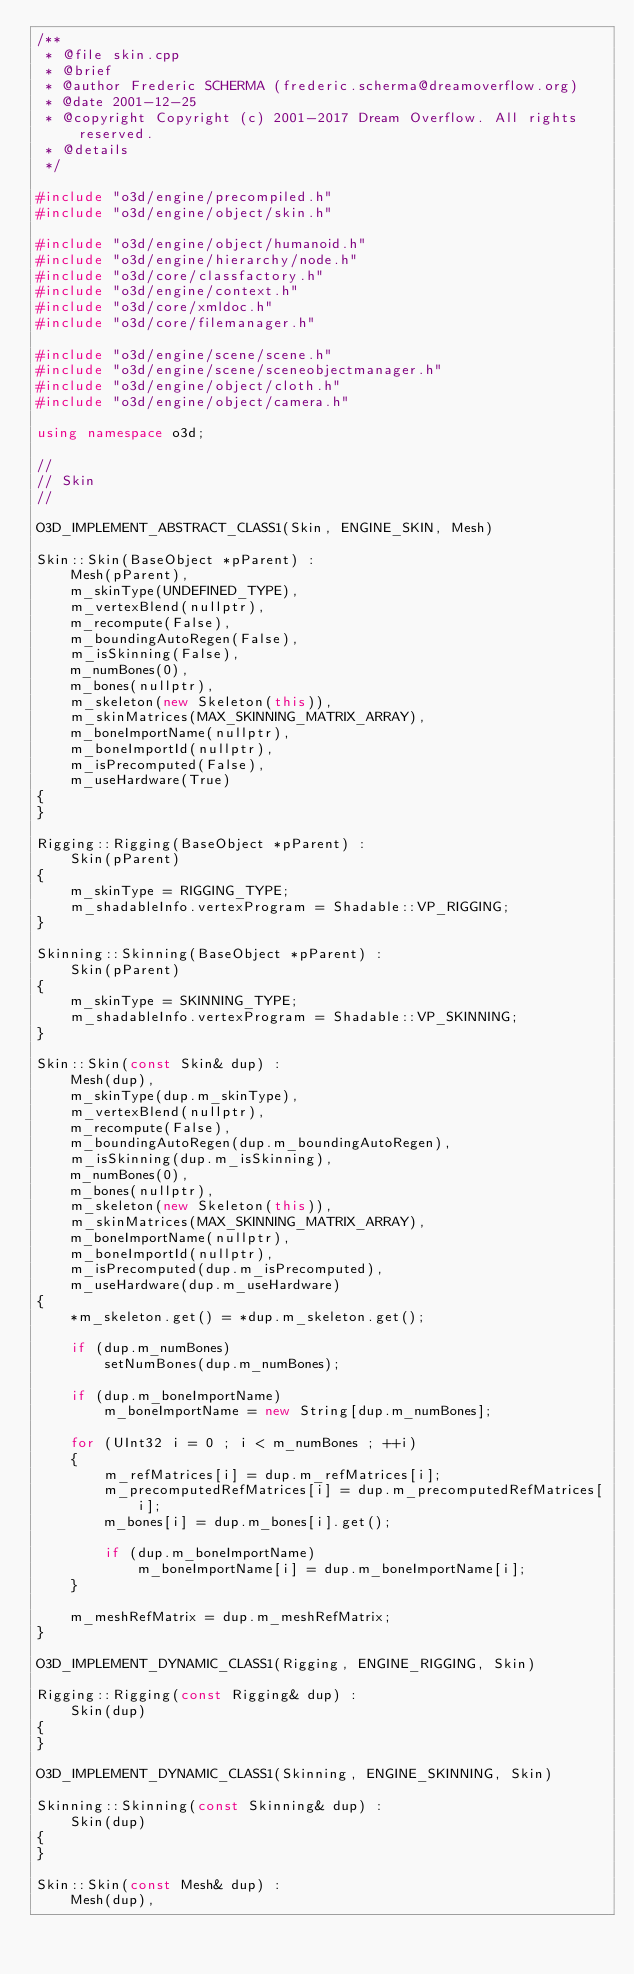Convert code to text. <code><loc_0><loc_0><loc_500><loc_500><_C++_>/**
 * @file skin.cpp
 * @brief 
 * @author Frederic SCHERMA (frederic.scherma@dreamoverflow.org)
 * @date 2001-12-25
 * @copyright Copyright (c) 2001-2017 Dream Overflow. All rights reserved.
 * @details 
 */

#include "o3d/engine/precompiled.h"
#include "o3d/engine/object/skin.h"

#include "o3d/engine/object/humanoid.h"
#include "o3d/engine/hierarchy/node.h"
#include "o3d/core/classfactory.h"
#include "o3d/engine/context.h"
#include "o3d/core/xmldoc.h"
#include "o3d/core/filemanager.h"

#include "o3d/engine/scene/scene.h"
#include "o3d/engine/scene/sceneobjectmanager.h"
#include "o3d/engine/object/cloth.h"
#include "o3d/engine/object/camera.h"

using namespace o3d;

//
// Skin
//

O3D_IMPLEMENT_ABSTRACT_CLASS1(Skin, ENGINE_SKIN, Mesh)

Skin::Skin(BaseObject *pParent) :
    Mesh(pParent),
    m_skinType(UNDEFINED_TYPE),
    m_vertexBlend(nullptr),
    m_recompute(False),
    m_boundingAutoRegen(False),
    m_isSkinning(False),
    m_numBones(0),
    m_bones(nullptr),
    m_skeleton(new Skeleton(this)),
    m_skinMatrices(MAX_SKINNING_MATRIX_ARRAY),
    m_boneImportName(nullptr),
    m_boneImportId(nullptr),
    m_isPrecomputed(False),
    m_useHardware(True)
{
}

Rigging::Rigging(BaseObject *pParent) :
    Skin(pParent)
{
    m_skinType = RIGGING_TYPE;
    m_shadableInfo.vertexProgram = Shadable::VP_RIGGING;
}

Skinning::Skinning(BaseObject *pParent) :
    Skin(pParent)
{
    m_skinType = SKINNING_TYPE;
    m_shadableInfo.vertexProgram = Shadable::VP_SKINNING;
}

Skin::Skin(const Skin& dup) :
    Mesh(dup),
    m_skinType(dup.m_skinType),
    m_vertexBlend(nullptr),
    m_recompute(False),
    m_boundingAutoRegen(dup.m_boundingAutoRegen),
    m_isSkinning(dup.m_isSkinning),
    m_numBones(0),
    m_bones(nullptr),
    m_skeleton(new Skeleton(this)),
    m_skinMatrices(MAX_SKINNING_MATRIX_ARRAY),
    m_boneImportName(nullptr),
    m_boneImportId(nullptr),
    m_isPrecomputed(dup.m_isPrecomputed),
    m_useHardware(dup.m_useHardware)
{
    *m_skeleton.get() = *dup.m_skeleton.get();

    if (dup.m_numBones)
        setNumBones(dup.m_numBones);

    if (dup.m_boneImportName)
        m_boneImportName = new String[dup.m_numBones];

    for (UInt32 i = 0 ; i < m_numBones ; ++i)
    {
        m_refMatrices[i] = dup.m_refMatrices[i];
        m_precomputedRefMatrices[i] = dup.m_precomputedRefMatrices[i];
        m_bones[i] = dup.m_bones[i].get();

        if (dup.m_boneImportName)
            m_boneImportName[i] = dup.m_boneImportName[i];
    }

    m_meshRefMatrix = dup.m_meshRefMatrix;
}

O3D_IMPLEMENT_DYNAMIC_CLASS1(Rigging, ENGINE_RIGGING, Skin)

Rigging::Rigging(const Rigging& dup) :
    Skin(dup)
{
}

O3D_IMPLEMENT_DYNAMIC_CLASS1(Skinning, ENGINE_SKINNING, Skin)

Skinning::Skinning(const Skinning& dup) :
    Skin(dup)
{
}

Skin::Skin(const Mesh& dup) :
    Mesh(dup),</code> 